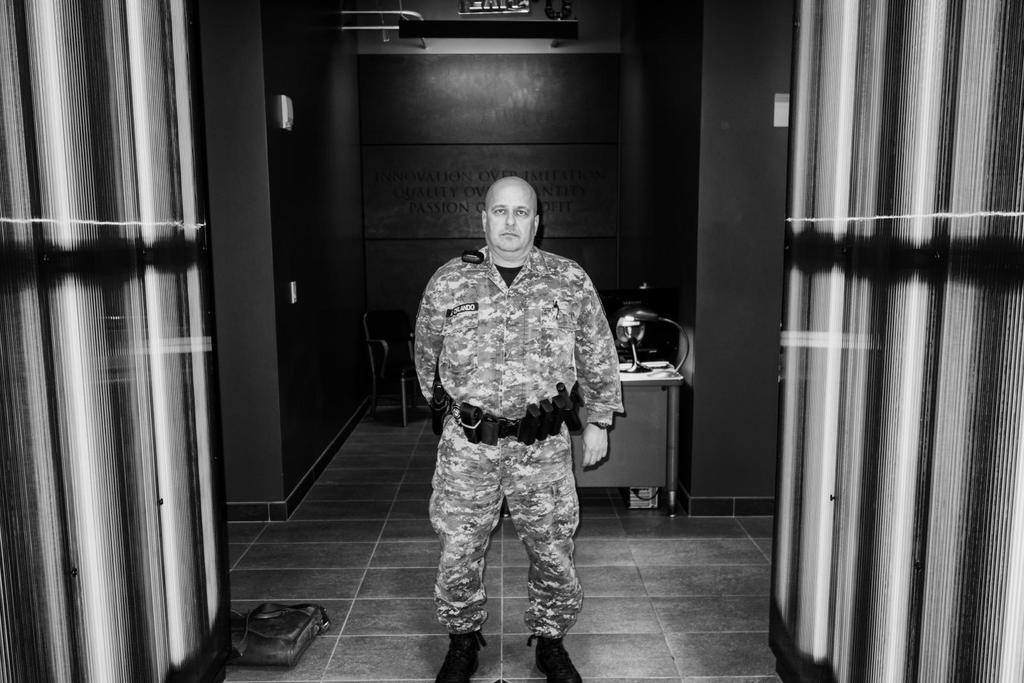Could you give a brief overview of what you see in this image? As we can see in the image there is a man wearing army dress. Behind him there is a lamp and there is a wall. 